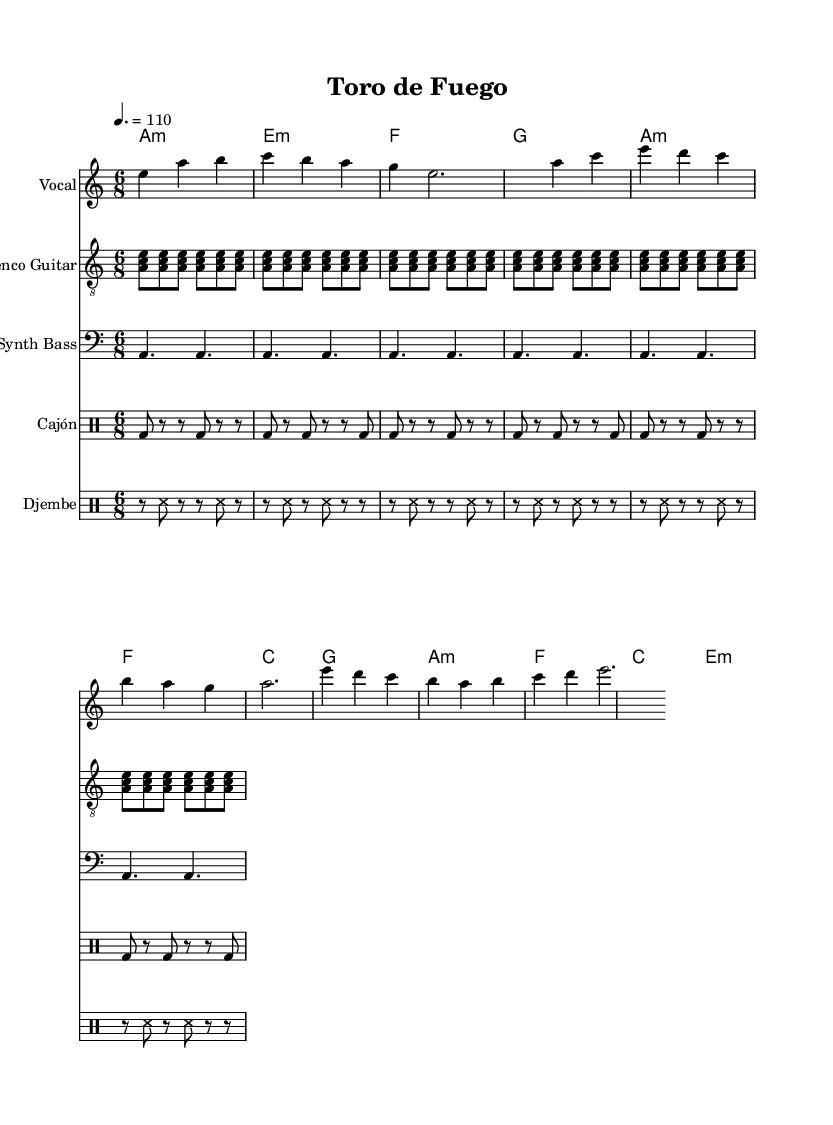What is the key signature of this music? The key signature is A minor, which has no sharps or flats.
Answer: A minor What is the time signature of the music? The time signature is found at the beginning and indicates how many beats are in a measure, in this case, it's 6/8.
Answer: 6/8 What is the tempo marking of the piece? The tempo marking at the beginning indicates the speed, which is 110 beats per minute.
Answer: 110 How many repetitions does the flamenco guitar pattern have? The flamenco guitar pattern is repeated 6 times, as indicated by the repeat symbol.
Answer: 6 What instruments are used in this piece? The music specifies five distinct parts: Vocal, Flamenco Guitar, Synth Bass, Cajón, and Djembe, which can be identified on the score.
Answer: Vocal, Flamenco Guitar, Synth Bass, Cajón, Djembe What is the first chord played in the harmonies? The first chord at the beginning of the harmony section is A minor, as indicated in the chord mode.
Answer: A minor Why might the combination of djembe and cajón be significant in this piece? The djembe and cajón add diverse rhythmic textures, emphasizing the Afro-Iberian electronic fusion's cultural identity, enriching the overall sound.
Answer: Cultural identity 